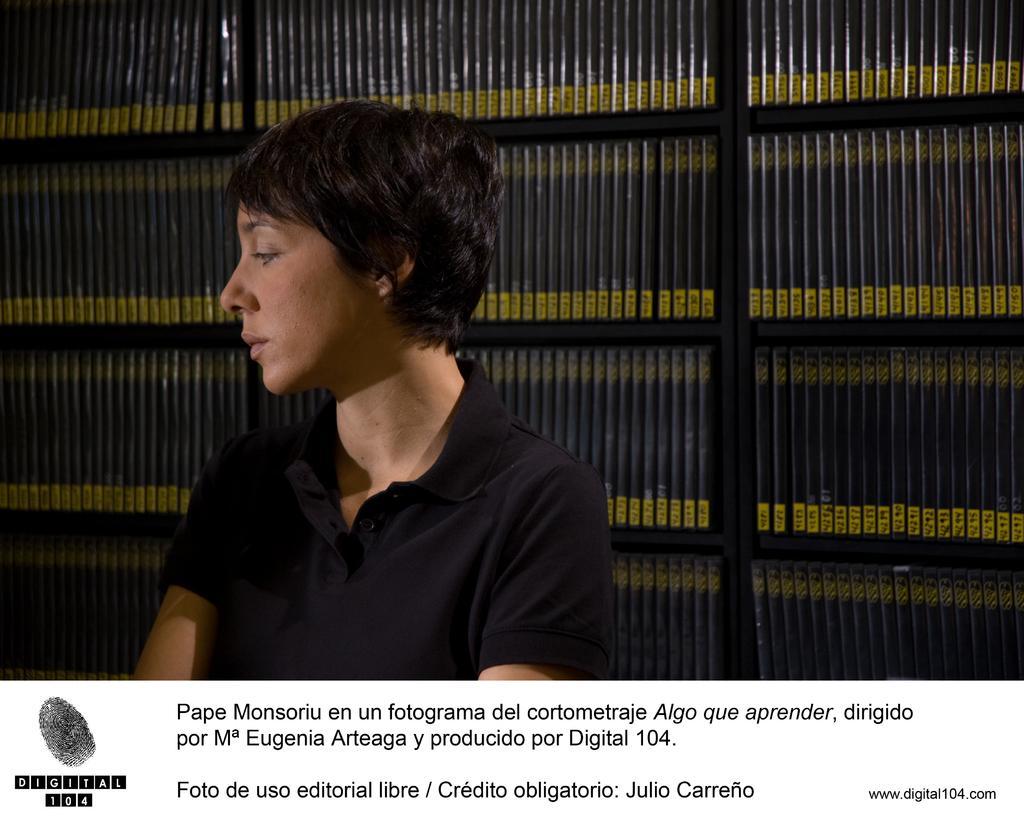Could you give a brief overview of what you see in this image? This image looks like an advertisement. There is text at the bottom. There is a person in the foreground. There is a rack with books in the background. 